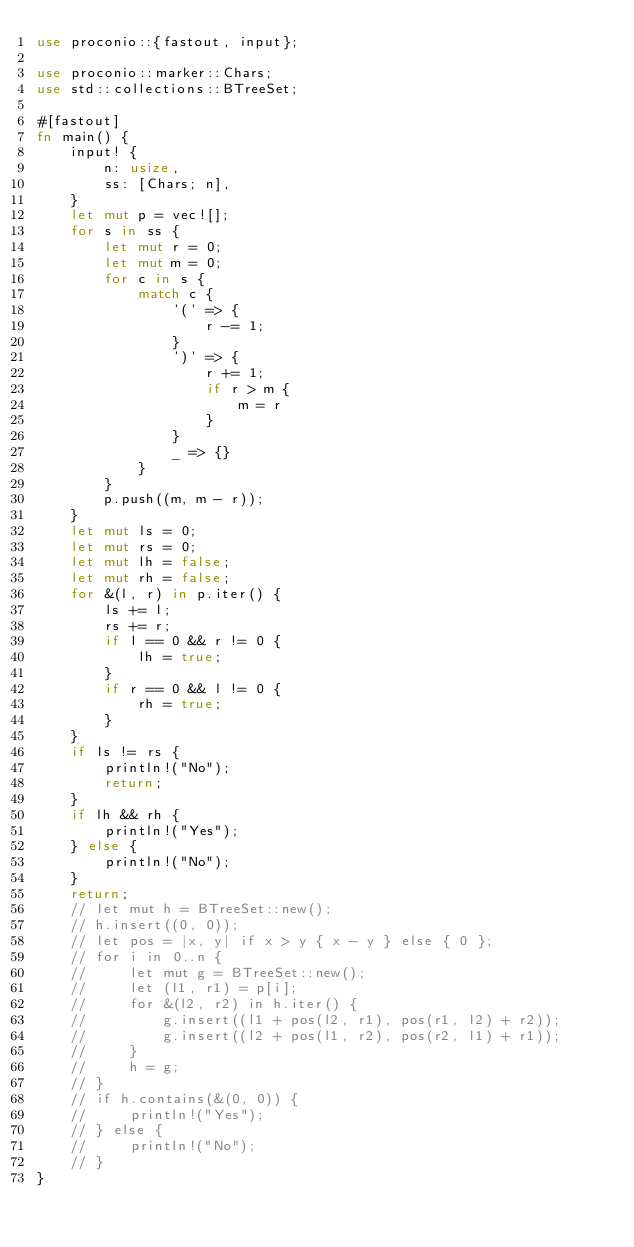Convert code to text. <code><loc_0><loc_0><loc_500><loc_500><_Rust_>use proconio::{fastout, input};

use proconio::marker::Chars;
use std::collections::BTreeSet;

#[fastout]
fn main() {
    input! {
        n: usize,
        ss: [Chars; n],
    }
    let mut p = vec![];
    for s in ss {
        let mut r = 0;
        let mut m = 0;
        for c in s {
            match c {
                '(' => {
                    r -= 1;
                }
                ')' => {
                    r += 1;
                    if r > m {
                        m = r
                    }
                }
                _ => {}
            }
        }
        p.push((m, m - r));
    }
    let mut ls = 0;
    let mut rs = 0;
    let mut lh = false;
    let mut rh = false;
    for &(l, r) in p.iter() {
        ls += l;
        rs += r;
        if l == 0 && r != 0 {
            lh = true;
        }
        if r == 0 && l != 0 {
            rh = true;
        }
    }
    if ls != rs {
        println!("No");
        return;
    }
    if lh && rh {
        println!("Yes");
    } else {
        println!("No");
    }
    return;
    // let mut h = BTreeSet::new();
    // h.insert((0, 0));
    // let pos = |x, y| if x > y { x - y } else { 0 };
    // for i in 0..n {
    //     let mut g = BTreeSet::new();
    //     let (l1, r1) = p[i];
    //     for &(l2, r2) in h.iter() {
    //         g.insert((l1 + pos(l2, r1), pos(r1, l2) + r2));
    //         g.insert((l2 + pos(l1, r2), pos(r2, l1) + r1));
    //     }
    //     h = g;
    // }
    // if h.contains(&(0, 0)) {
    //     println!("Yes");
    // } else {
    //     println!("No");
    // }
}
</code> 